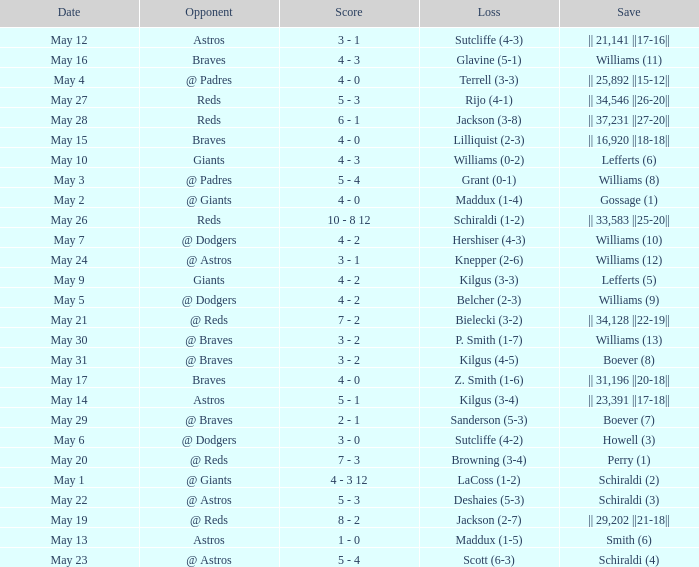Name the loss for may 1 LaCoss (1-2). 